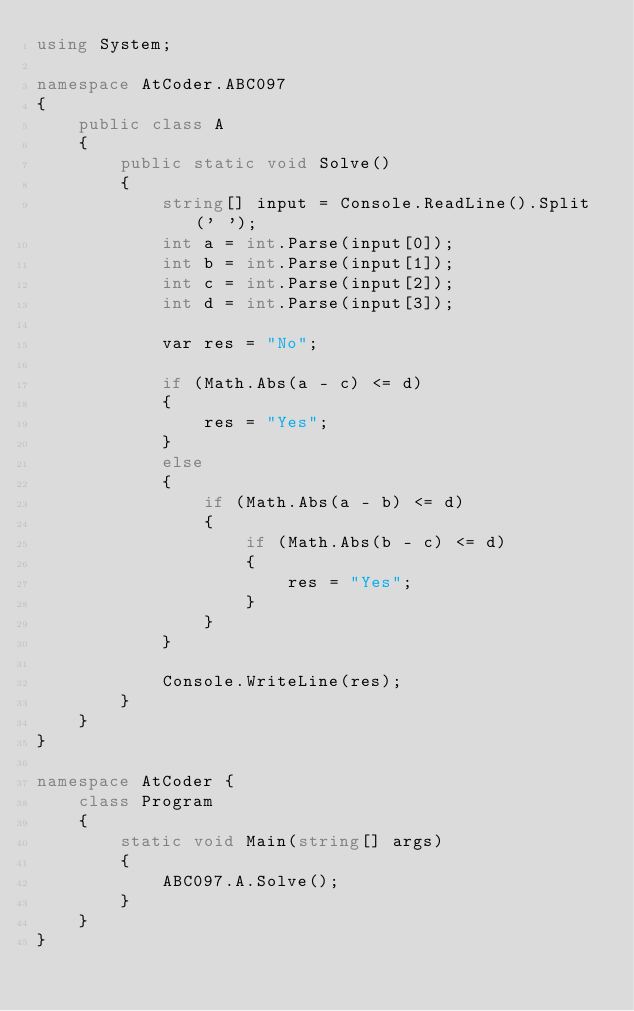<code> <loc_0><loc_0><loc_500><loc_500><_C#_>using System;

namespace AtCoder.ABC097
{
    public class A
    {
        public static void Solve()
        {
            string[] input = Console.ReadLine().Split(' ');
            int a = int.Parse(input[0]);
            int b = int.Parse(input[1]);
            int c = int.Parse(input[2]);
            int d = int.Parse(input[3]);

            var res = "No";
            
            if (Math.Abs(a - c) <= d)
            {
                res = "Yes";
            }
            else
            {
                if (Math.Abs(a - b) <= d)
                {
                    if (Math.Abs(b - c) <= d)
                    {
                        res = "Yes";
                    }
                }
            }
        
            Console.WriteLine(res);
        }    
    }
}

namespace AtCoder {
    class Program
    {
        static void Main(string[] args)
        {
            ABC097.A.Solve();
        }
    }
}
</code> 